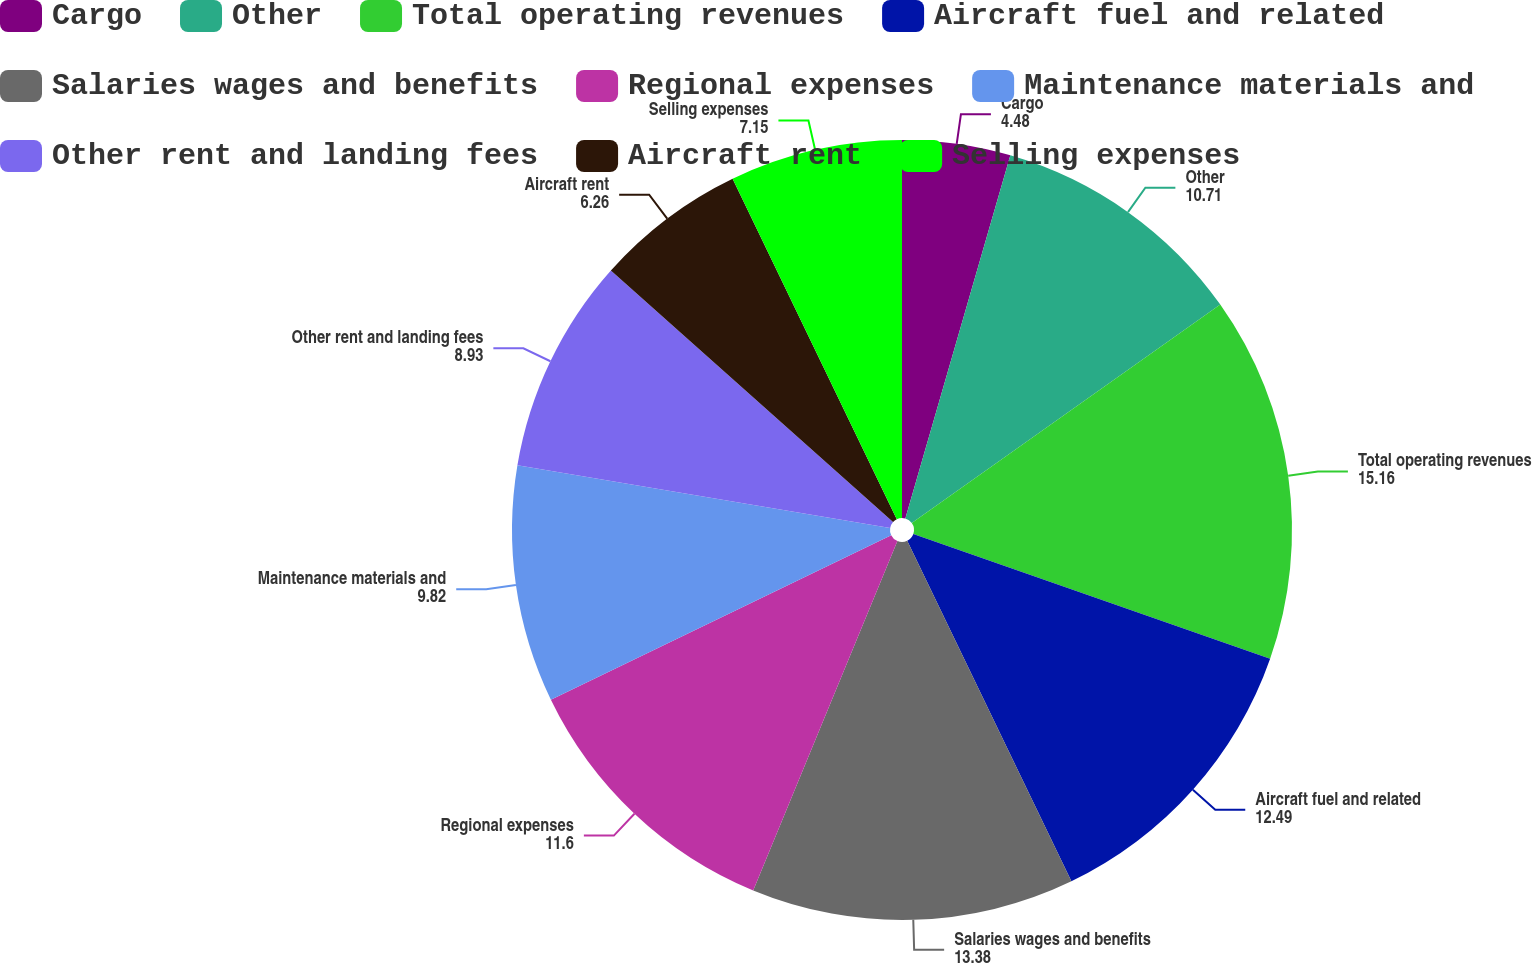Convert chart. <chart><loc_0><loc_0><loc_500><loc_500><pie_chart><fcel>Cargo<fcel>Other<fcel>Total operating revenues<fcel>Aircraft fuel and related<fcel>Salaries wages and benefits<fcel>Regional expenses<fcel>Maintenance materials and<fcel>Other rent and landing fees<fcel>Aircraft rent<fcel>Selling expenses<nl><fcel>4.48%<fcel>10.71%<fcel>15.16%<fcel>12.49%<fcel>13.38%<fcel>11.6%<fcel>9.82%<fcel>8.93%<fcel>6.26%<fcel>7.15%<nl></chart> 